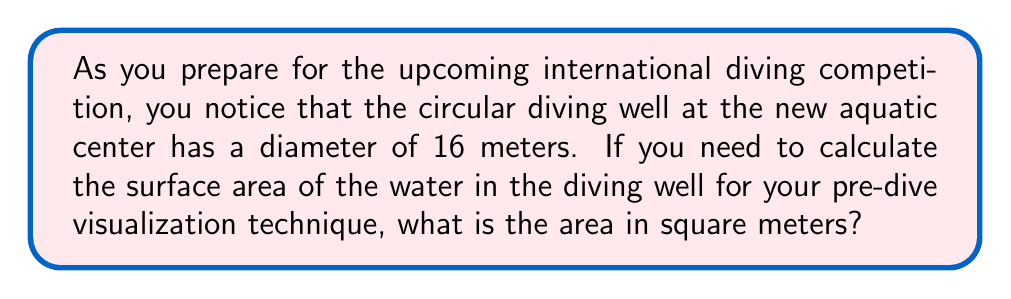Teach me how to tackle this problem. Let's solve this step-by-step:

1) The formula for the area of a circle is:

   $$A = \pi r^2$$

   where $A$ is the area and $r$ is the radius.

2) We're given the diameter, which is 16 meters. The radius is half of the diameter:

   $$r = \frac{16}{2} = 8 \text{ meters}$$

3) Now we can substitute this into our formula:

   $$A = \pi (8)^2$$

4) Simplify the exponent:

   $$A = \pi (64)$$

5) Multiply:

   $$A = 64\pi \text{ square meters}$$

6) If we need to give a decimal approximation, we can use $\pi \approx 3.14159$:

   $$A \approx 64 \times 3.14159 \approx 201.06176 \text{ square meters}$$
Answer: $64\pi$ or approximately 201.06 square meters 